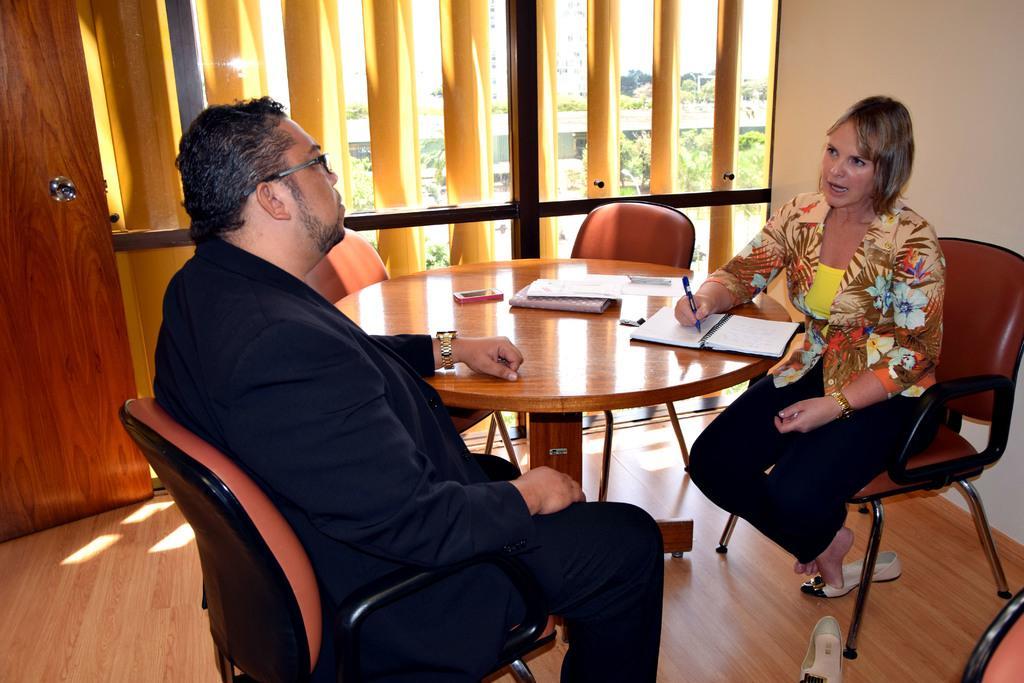Please provide a concise description of this image. In this image there are 2 persons sitting on a chair having a conversation with each other a woman is holding a pen and is writing on a book. There is a round table here on this table there are some papers. In the background we can see a window, trees outside the window, the door behind this man. 